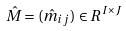Convert formula to latex. <formula><loc_0><loc_0><loc_500><loc_500>\hat { M } = ( \hat { m } _ { i j } ) \in R ^ { I \times J }</formula> 